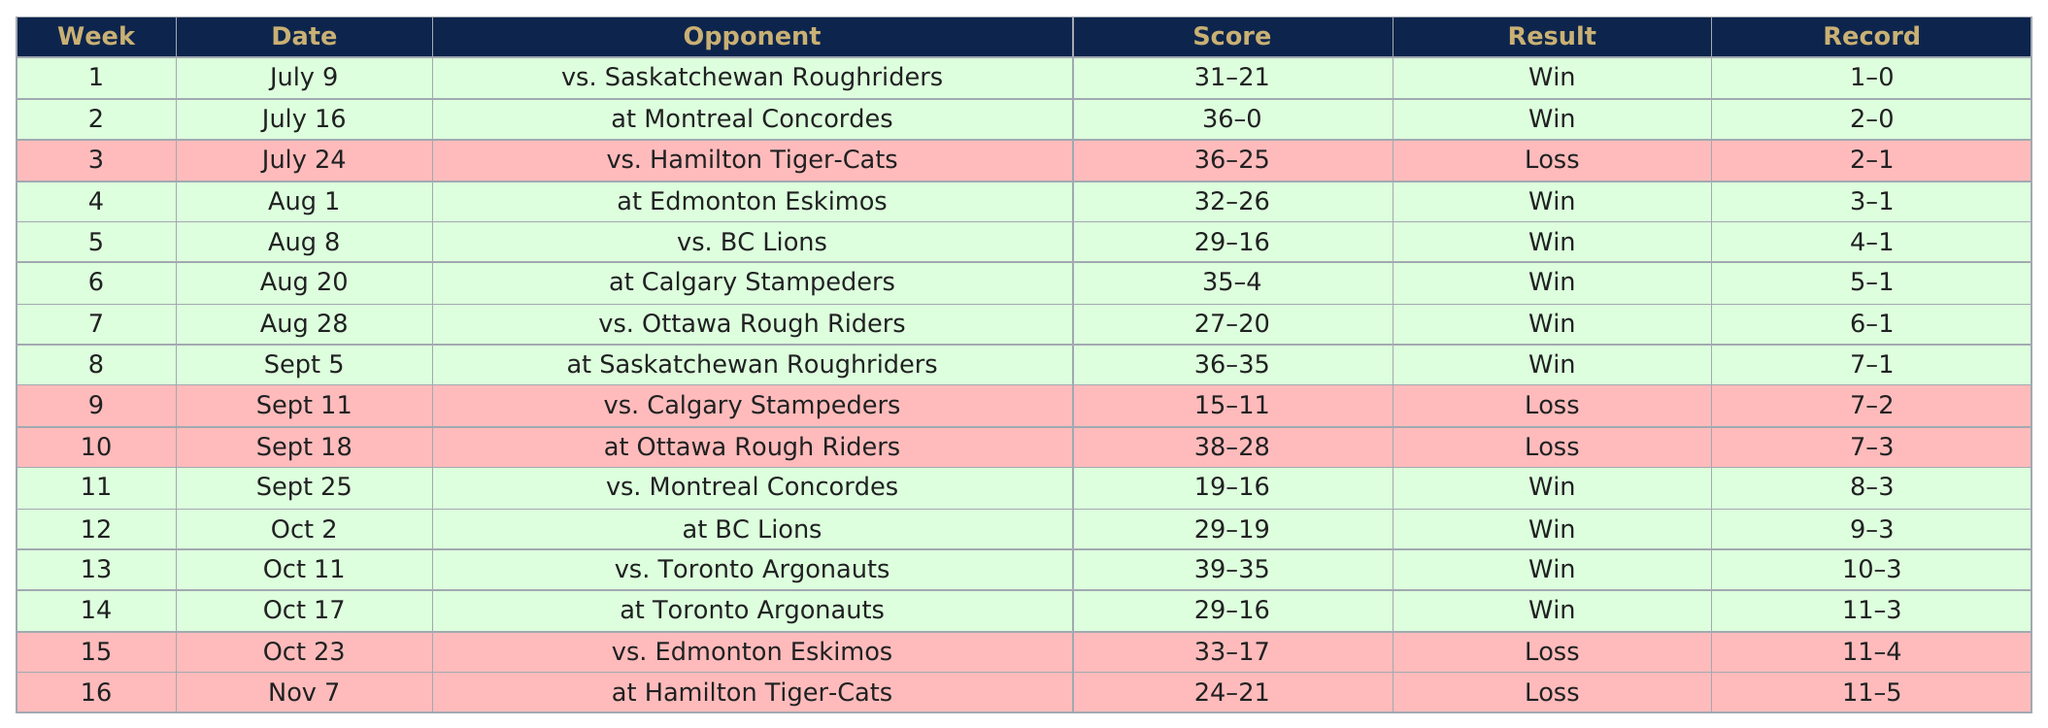List a handful of essential elements in this visual. The Bombers scored the least points on September 11. After the first loss of the season, the next opponent for the Edmonton Eskimos is yet to be determined. Four teams have played against them in October. On average, our opponents have scored 29.2 points in the games we have lost this season. The total points scored by the bombers against the BC Lions was 58. 